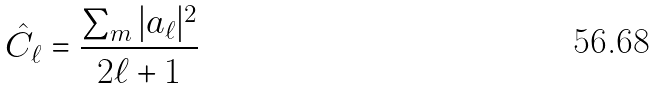Convert formula to latex. <formula><loc_0><loc_0><loc_500><loc_500>\hat { C _ { \ell } } = \frac { \sum _ { m } | a _ { \ell } | ^ { 2 } } { 2 \ell + 1 }</formula> 